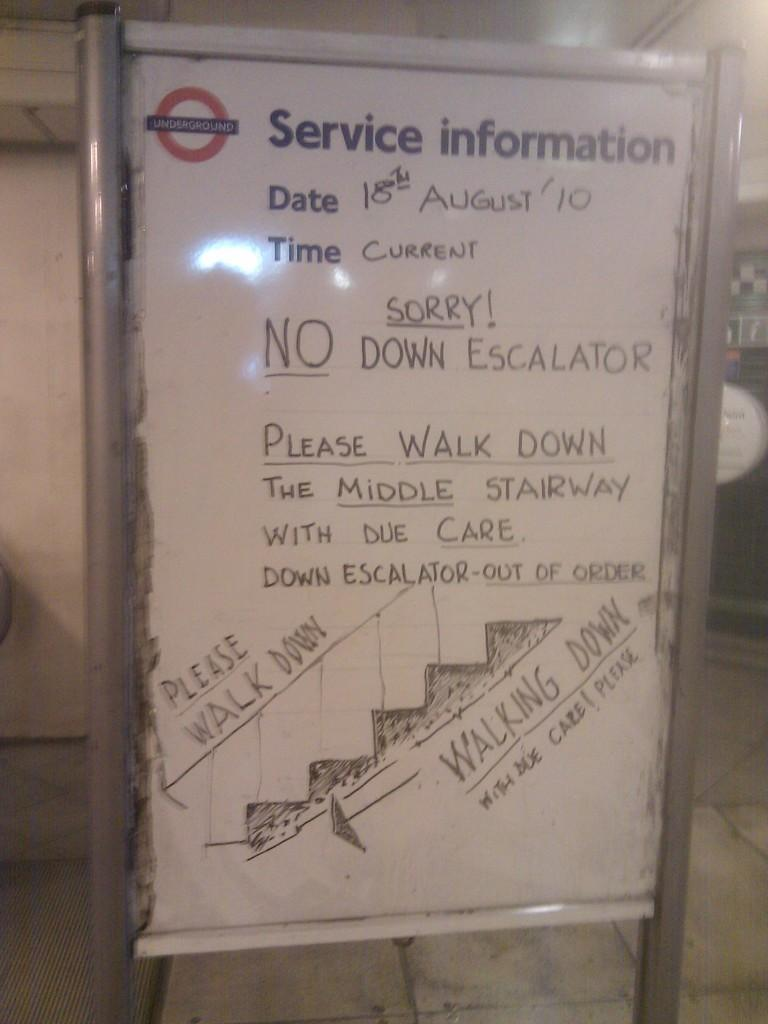<image>
Render a clear and concise summary of the photo. A dry erase board that is titled Service Information 